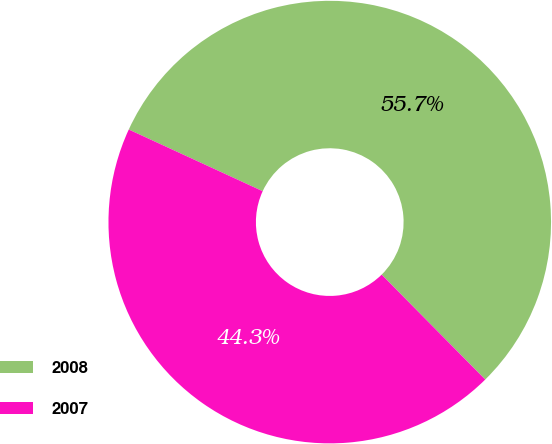Convert chart to OTSL. <chart><loc_0><loc_0><loc_500><loc_500><pie_chart><fcel>2008<fcel>2007<nl><fcel>55.73%<fcel>44.27%<nl></chart> 